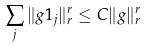Convert formula to latex. <formula><loc_0><loc_0><loc_500><loc_500>\sum _ { j } \| g \mathbb { m } { 1 } _ { j } \| _ { r } ^ { r } \leq C \| g \| _ { r } ^ { r }</formula> 